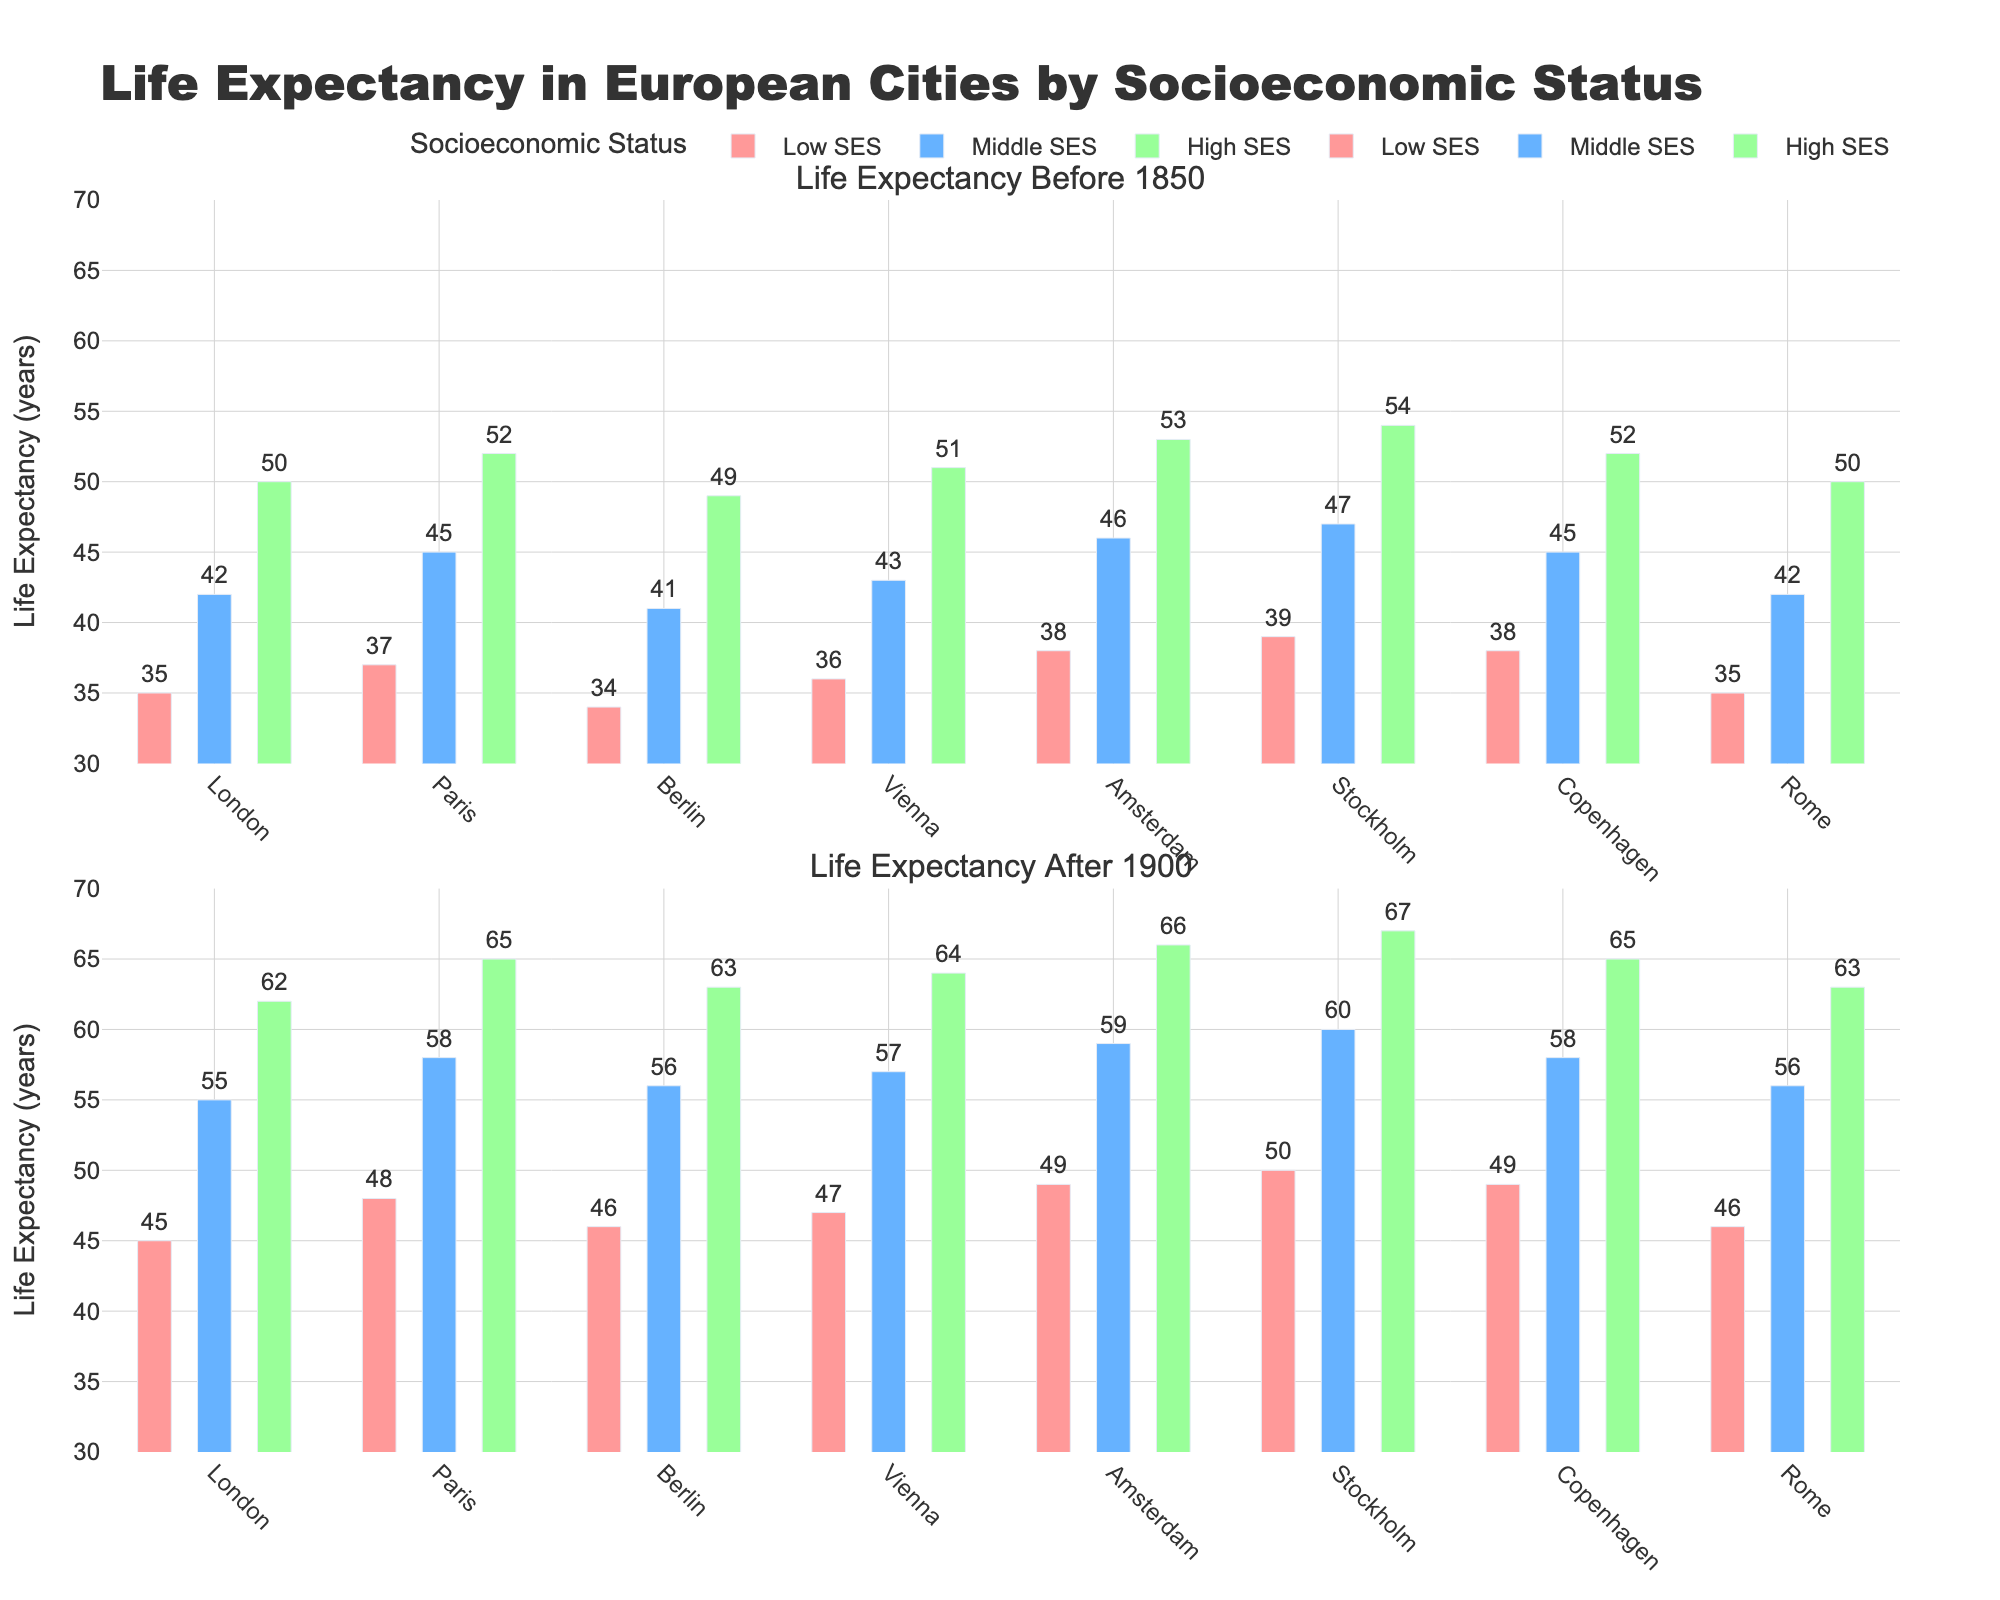Which city shows the highest increase in life expectancy for the low socioeconomic status group between before 1850 and after 1900? Find the bar for the low SES group in both periods for each city, then calculate the difference between them. Compare these differences to find the largest one, which is for Stockholm (50 - 39).
Answer: Stockholm What is the average life expectancy for the middle socioeconomic status group in European cities after 1900? Sum the life expectancy values for the middle SES group after 1900 (55, 58, 56, 57, 59, 60, 58, 56) and divide by the number of cities (8). (55 + 58 + 56 + 57 + 59 + 60 + 58 + 56) / 8 = 459 / 8 = 57.375
Answer: 57.4 Which city has the smallest change in life expectancy for the high socioeconomic status group between the two periods? Calculate the differences in life expectancy for the high SES group for each city and find the smallest. The smallest change is for Copenhagen (65 - 52), which is 13.
Answer: Copenhagen Comparing Berlin and Rome, which city had a higher life expectancy for the low socioeconomic status group before 1850? Look at the bar heights for Berlin and Rome's low SES group before 1850. Berlin's value is 34, and Rome's is 35.
Answer: Rome How much greater is the life expectancy of the high socioeconomic status group in Amsterdam after 1900 compared to Berlin before 1850? Find the life expectancy for Amsterdam's high SES group after 1900 (66) and Berlin's high SES before 1850 (49), then subtract the latter from the former. 66 - 49 = 17
Answer: 17 What was the difference in life expectancy between low and high SES groups in Vienna before 1850? For Vienna before 1850, find the life expectancy of the low SES (36) and high SES (51) groups, then subtract the low SES value from the high SES value. 51 - 36 = 15
Answer: 15 Among the six cities listed, which city's middle SES group saw the largest improvement in life expectancy from before 1850 to after 1900? Calculate the increase in life expectancy for the middle SES group from before 1850 to after 1900 for each city and compare the differences: London (55 - 42), Paris (58 - 45), Berlin (56 - 41), Vienna (57 - 43), Amsterdam (59 - 46), Stockholm (60 - 47), Copenhagen (58 - 45), Rome (56 - 42). The largest increase is in London (55 - 42 = 13).
Answer: London What is the total life expectancy for all SES groups in Paris after 1900? Sum the life expectancy values for all SES groups in Paris after 1900 (48 + 58 + 65). 48 + 58 + 65 = 171
Answer: 171 How does the life expectancy of the middle SES group in Stockholm before 1850 compare to that in Vienna after 1900? Find the life expectancy values for the middle SES group in Stockholm before 1850 (47) and in Vienna after 1900 (57), then compare them. 47 is less than 57.
Answer: Less 